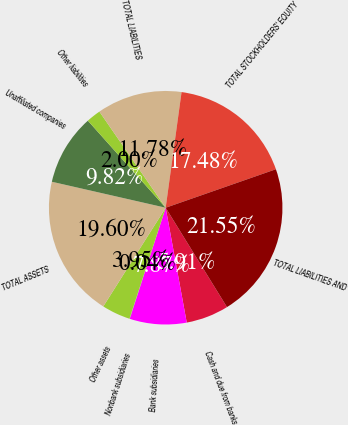<chart> <loc_0><loc_0><loc_500><loc_500><pie_chart><fcel>Cash and due from banks<fcel>Bank subsidiaries<fcel>Nonbank subsidiaries<fcel>Other assets<fcel>TOTAL ASSETS<fcel>Unaffiliated companies<fcel>Other liabilities<fcel>TOTAL LIABILITIES<fcel>TOTAL STOCKHOLDERS' EQUITY<fcel>TOTAL LIABILITIES AND<nl><fcel>5.91%<fcel>7.87%<fcel>0.04%<fcel>3.95%<fcel>19.6%<fcel>9.82%<fcel>2.0%<fcel>11.78%<fcel>17.48%<fcel>21.55%<nl></chart> 